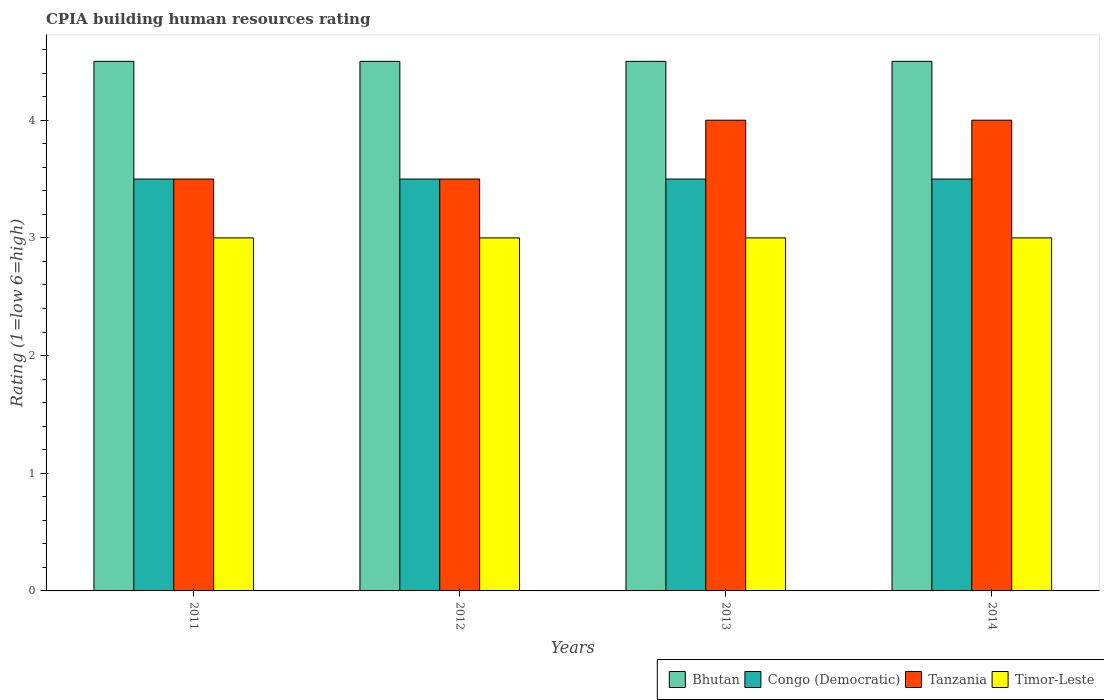How many different coloured bars are there?
Your response must be concise. 4. How many groups of bars are there?
Offer a very short reply. 4. Are the number of bars per tick equal to the number of legend labels?
Your response must be concise. Yes. Are the number of bars on each tick of the X-axis equal?
Offer a terse response. Yes. What is the CPIA rating in Tanzania in 2011?
Your response must be concise. 3.5. Across all years, what is the maximum CPIA rating in Congo (Democratic)?
Offer a terse response. 3.5. In which year was the CPIA rating in Bhutan maximum?
Offer a terse response. 2011. In which year was the CPIA rating in Tanzania minimum?
Keep it short and to the point. 2011. What is the difference between the CPIA rating in Tanzania in 2014 and the CPIA rating in Bhutan in 2013?
Your answer should be very brief. -0.5. What is the average CPIA rating in Bhutan per year?
Provide a succinct answer. 4.5. In the year 2013, what is the difference between the CPIA rating in Tanzania and CPIA rating in Congo (Democratic)?
Your answer should be compact. 0.5. What is the ratio of the CPIA rating in Tanzania in 2011 to that in 2013?
Offer a terse response. 0.88. Is the difference between the CPIA rating in Tanzania in 2012 and 2013 greater than the difference between the CPIA rating in Congo (Democratic) in 2012 and 2013?
Your response must be concise. No. What is the difference between the highest and the second highest CPIA rating in Bhutan?
Make the answer very short. 0. What does the 4th bar from the left in 2011 represents?
Provide a short and direct response. Timor-Leste. What does the 4th bar from the right in 2014 represents?
Offer a very short reply. Bhutan. Is it the case that in every year, the sum of the CPIA rating in Bhutan and CPIA rating in Tanzania is greater than the CPIA rating in Timor-Leste?
Provide a succinct answer. Yes. How many bars are there?
Give a very brief answer. 16. Are all the bars in the graph horizontal?
Your answer should be compact. No. How many years are there in the graph?
Provide a succinct answer. 4. Are the values on the major ticks of Y-axis written in scientific E-notation?
Your answer should be compact. No. Does the graph contain any zero values?
Your answer should be compact. No. Where does the legend appear in the graph?
Offer a terse response. Bottom right. How many legend labels are there?
Make the answer very short. 4. How are the legend labels stacked?
Offer a terse response. Horizontal. What is the title of the graph?
Provide a short and direct response. CPIA building human resources rating. What is the label or title of the X-axis?
Provide a short and direct response. Years. What is the Rating (1=low 6=high) of Congo (Democratic) in 2011?
Provide a succinct answer. 3.5. What is the Rating (1=low 6=high) of Tanzania in 2011?
Your answer should be very brief. 3.5. What is the Rating (1=low 6=high) of Bhutan in 2012?
Your answer should be compact. 4.5. What is the Rating (1=low 6=high) of Congo (Democratic) in 2012?
Keep it short and to the point. 3.5. Across all years, what is the maximum Rating (1=low 6=high) in Bhutan?
Provide a succinct answer. 4.5. Across all years, what is the maximum Rating (1=low 6=high) in Tanzania?
Make the answer very short. 4. Across all years, what is the minimum Rating (1=low 6=high) in Bhutan?
Your response must be concise. 4.5. Across all years, what is the minimum Rating (1=low 6=high) of Tanzania?
Make the answer very short. 3.5. What is the difference between the Rating (1=low 6=high) of Bhutan in 2011 and that in 2012?
Your response must be concise. 0. What is the difference between the Rating (1=low 6=high) in Bhutan in 2011 and that in 2013?
Your response must be concise. 0. What is the difference between the Rating (1=low 6=high) in Tanzania in 2011 and that in 2013?
Offer a very short reply. -0.5. What is the difference between the Rating (1=low 6=high) in Timor-Leste in 2011 and that in 2013?
Give a very brief answer. 0. What is the difference between the Rating (1=low 6=high) in Tanzania in 2011 and that in 2014?
Keep it short and to the point. -0.5. What is the difference between the Rating (1=low 6=high) of Timor-Leste in 2011 and that in 2014?
Your answer should be very brief. 0. What is the difference between the Rating (1=low 6=high) in Tanzania in 2012 and that in 2013?
Provide a succinct answer. -0.5. What is the difference between the Rating (1=low 6=high) in Timor-Leste in 2012 and that in 2013?
Keep it short and to the point. 0. What is the difference between the Rating (1=low 6=high) in Bhutan in 2012 and that in 2014?
Ensure brevity in your answer.  0. What is the difference between the Rating (1=low 6=high) in Congo (Democratic) in 2012 and that in 2014?
Offer a very short reply. 0. What is the difference between the Rating (1=low 6=high) in Congo (Democratic) in 2013 and that in 2014?
Ensure brevity in your answer.  0. What is the difference between the Rating (1=low 6=high) of Timor-Leste in 2013 and that in 2014?
Your answer should be very brief. 0. What is the difference between the Rating (1=low 6=high) of Bhutan in 2011 and the Rating (1=low 6=high) of Congo (Democratic) in 2012?
Offer a very short reply. 1. What is the difference between the Rating (1=low 6=high) in Bhutan in 2011 and the Rating (1=low 6=high) in Timor-Leste in 2013?
Keep it short and to the point. 1.5. What is the difference between the Rating (1=low 6=high) in Tanzania in 2011 and the Rating (1=low 6=high) in Timor-Leste in 2013?
Make the answer very short. 0.5. What is the difference between the Rating (1=low 6=high) of Bhutan in 2011 and the Rating (1=low 6=high) of Congo (Democratic) in 2014?
Give a very brief answer. 1. What is the difference between the Rating (1=low 6=high) in Bhutan in 2011 and the Rating (1=low 6=high) in Tanzania in 2014?
Your answer should be very brief. 0.5. What is the difference between the Rating (1=low 6=high) of Congo (Democratic) in 2011 and the Rating (1=low 6=high) of Tanzania in 2014?
Keep it short and to the point. -0.5. What is the difference between the Rating (1=low 6=high) of Congo (Democratic) in 2011 and the Rating (1=low 6=high) of Timor-Leste in 2014?
Make the answer very short. 0.5. What is the difference between the Rating (1=low 6=high) in Bhutan in 2012 and the Rating (1=low 6=high) in Timor-Leste in 2013?
Offer a terse response. 1.5. What is the difference between the Rating (1=low 6=high) in Congo (Democratic) in 2012 and the Rating (1=low 6=high) in Tanzania in 2013?
Offer a very short reply. -0.5. What is the difference between the Rating (1=low 6=high) in Tanzania in 2012 and the Rating (1=low 6=high) in Timor-Leste in 2013?
Your response must be concise. 0.5. What is the difference between the Rating (1=low 6=high) of Bhutan in 2012 and the Rating (1=low 6=high) of Tanzania in 2014?
Make the answer very short. 0.5. What is the difference between the Rating (1=low 6=high) in Tanzania in 2012 and the Rating (1=low 6=high) in Timor-Leste in 2014?
Provide a succinct answer. 0.5. What is the difference between the Rating (1=low 6=high) of Bhutan in 2013 and the Rating (1=low 6=high) of Congo (Democratic) in 2014?
Your answer should be compact. 1. What is the difference between the Rating (1=low 6=high) in Bhutan in 2013 and the Rating (1=low 6=high) in Tanzania in 2014?
Provide a short and direct response. 0.5. What is the difference between the Rating (1=low 6=high) in Bhutan in 2013 and the Rating (1=low 6=high) in Timor-Leste in 2014?
Your answer should be compact. 1.5. What is the difference between the Rating (1=low 6=high) in Tanzania in 2013 and the Rating (1=low 6=high) in Timor-Leste in 2014?
Provide a short and direct response. 1. What is the average Rating (1=low 6=high) of Bhutan per year?
Give a very brief answer. 4.5. What is the average Rating (1=low 6=high) in Congo (Democratic) per year?
Provide a succinct answer. 3.5. What is the average Rating (1=low 6=high) of Tanzania per year?
Offer a terse response. 3.75. What is the average Rating (1=low 6=high) of Timor-Leste per year?
Your answer should be compact. 3. In the year 2011, what is the difference between the Rating (1=low 6=high) of Bhutan and Rating (1=low 6=high) of Congo (Democratic)?
Offer a very short reply. 1. In the year 2012, what is the difference between the Rating (1=low 6=high) of Bhutan and Rating (1=low 6=high) of Tanzania?
Provide a short and direct response. 1. In the year 2012, what is the difference between the Rating (1=low 6=high) in Bhutan and Rating (1=low 6=high) in Timor-Leste?
Make the answer very short. 1.5. In the year 2012, what is the difference between the Rating (1=low 6=high) of Congo (Democratic) and Rating (1=low 6=high) of Tanzania?
Offer a very short reply. 0. In the year 2012, what is the difference between the Rating (1=low 6=high) in Tanzania and Rating (1=low 6=high) in Timor-Leste?
Offer a terse response. 0.5. In the year 2013, what is the difference between the Rating (1=low 6=high) in Bhutan and Rating (1=low 6=high) in Tanzania?
Your response must be concise. 0.5. In the year 2013, what is the difference between the Rating (1=low 6=high) of Bhutan and Rating (1=low 6=high) of Timor-Leste?
Give a very brief answer. 1.5. In the year 2013, what is the difference between the Rating (1=low 6=high) of Congo (Democratic) and Rating (1=low 6=high) of Tanzania?
Make the answer very short. -0.5. In the year 2013, what is the difference between the Rating (1=low 6=high) of Tanzania and Rating (1=low 6=high) of Timor-Leste?
Provide a succinct answer. 1. In the year 2014, what is the difference between the Rating (1=low 6=high) of Bhutan and Rating (1=low 6=high) of Timor-Leste?
Offer a very short reply. 1.5. In the year 2014, what is the difference between the Rating (1=low 6=high) of Congo (Democratic) and Rating (1=low 6=high) of Tanzania?
Your answer should be compact. -0.5. In the year 2014, what is the difference between the Rating (1=low 6=high) in Congo (Democratic) and Rating (1=low 6=high) in Timor-Leste?
Your answer should be very brief. 0.5. In the year 2014, what is the difference between the Rating (1=low 6=high) of Tanzania and Rating (1=low 6=high) of Timor-Leste?
Offer a terse response. 1. What is the ratio of the Rating (1=low 6=high) in Bhutan in 2011 to that in 2012?
Provide a short and direct response. 1. What is the ratio of the Rating (1=low 6=high) in Tanzania in 2011 to that in 2012?
Provide a short and direct response. 1. What is the ratio of the Rating (1=low 6=high) of Timor-Leste in 2011 to that in 2013?
Provide a succinct answer. 1. What is the ratio of the Rating (1=low 6=high) of Bhutan in 2012 to that in 2013?
Provide a succinct answer. 1. What is the ratio of the Rating (1=low 6=high) in Congo (Democratic) in 2012 to that in 2013?
Your answer should be compact. 1. What is the ratio of the Rating (1=low 6=high) of Timor-Leste in 2012 to that in 2013?
Your answer should be compact. 1. What is the ratio of the Rating (1=low 6=high) in Tanzania in 2012 to that in 2014?
Ensure brevity in your answer.  0.88. What is the ratio of the Rating (1=low 6=high) of Timor-Leste in 2012 to that in 2014?
Offer a terse response. 1. What is the difference between the highest and the second highest Rating (1=low 6=high) of Bhutan?
Offer a terse response. 0. What is the difference between the highest and the lowest Rating (1=low 6=high) in Bhutan?
Your answer should be very brief. 0. What is the difference between the highest and the lowest Rating (1=low 6=high) in Congo (Democratic)?
Your answer should be compact. 0. What is the difference between the highest and the lowest Rating (1=low 6=high) of Tanzania?
Offer a very short reply. 0.5. What is the difference between the highest and the lowest Rating (1=low 6=high) of Timor-Leste?
Give a very brief answer. 0. 